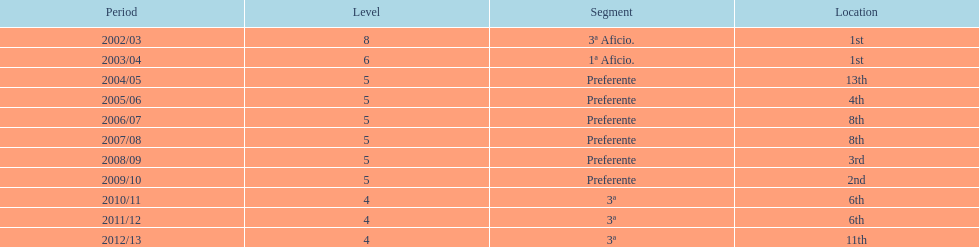Parse the full table. {'header': ['Period', 'Level', 'Segment', 'Location'], 'rows': [['2002/03', '8', '3ª Aficio.', '1st'], ['2003/04', '6', '1ª Aficio.', '1st'], ['2004/05', '5', 'Preferente', '13th'], ['2005/06', '5', 'Preferente', '4th'], ['2006/07', '5', 'Preferente', '8th'], ['2007/08', '5', 'Preferente', '8th'], ['2008/09', '5', 'Preferente', '3rd'], ['2009/10', '5', 'Preferente', '2nd'], ['2010/11', '4', '3ª', '6th'], ['2011/12', '4', '3ª', '6th'], ['2012/13', '4', '3ª', '11th']]} Which division ranked above aficio 1a and 3a? Preferente. 